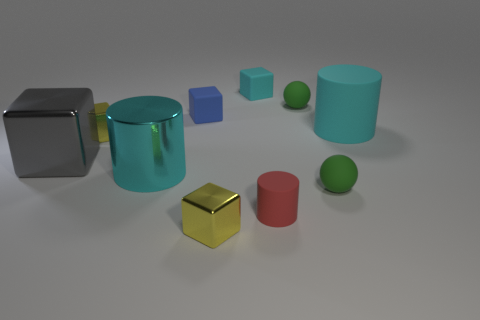There is a cylinder behind the large thing to the left of the large metal cylinder; what is it made of?
Offer a terse response. Rubber. There is a cyan thing that is on the right side of the large cyan shiny cylinder and to the left of the big cyan rubber object; what is its shape?
Offer a very short reply. Cube. There is a metallic object that is the same shape as the red matte object; what is its size?
Give a very brief answer. Large. Are there fewer cyan rubber things that are to the left of the gray cube than big purple metal cylinders?
Give a very brief answer. No. What size is the cyan matte object right of the cyan matte block?
Ensure brevity in your answer.  Large. What is the color of the big metallic object that is the same shape as the tiny blue rubber object?
Provide a short and direct response. Gray. How many small things are the same color as the large rubber object?
Make the answer very short. 1. Is there a shiny thing left of the big cyan object to the right of the green ball in front of the blue cube?
Give a very brief answer. Yes. How many small green spheres are made of the same material as the tiny blue object?
Keep it short and to the point. 2. There is a cyan object that is behind the tiny blue block; is its size the same as the sphere that is in front of the large matte object?
Provide a short and direct response. Yes. 